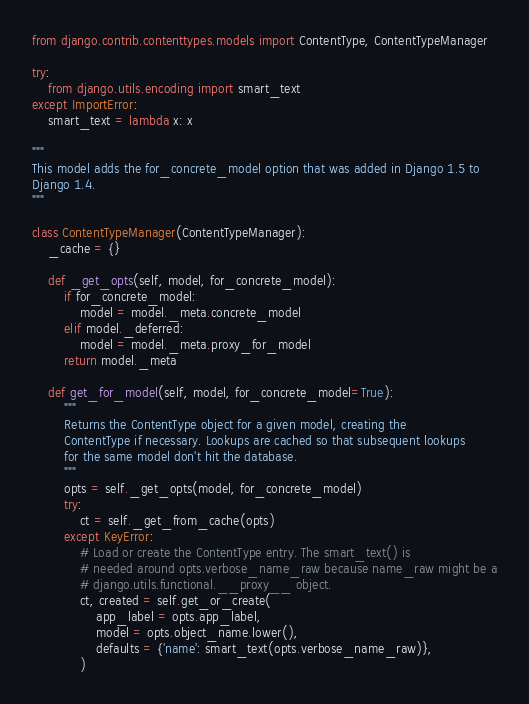Convert code to text. <code><loc_0><loc_0><loc_500><loc_500><_Python_>from django.contrib.contenttypes.models import ContentType, ContentTypeManager

try:
    from django.utils.encoding import smart_text
except ImportError:
    smart_text = lambda x: x

"""
This model adds the for_concrete_model option that was added in Django 1.5 to
Django 1.4.
"""

class ContentTypeManager(ContentTypeManager):
    _cache = {}

    def _get_opts(self, model, for_concrete_model):
        if for_concrete_model:
            model = model._meta.concrete_model
        elif model._deferred:
            model = model._meta.proxy_for_model
        return model._meta

    def get_for_model(self, model, for_concrete_model=True):
        """
        Returns the ContentType object for a given model, creating the
        ContentType if necessary. Lookups are cached so that subsequent lookups
        for the same model don't hit the database.
        """
        opts = self._get_opts(model, for_concrete_model)
        try:
            ct = self._get_from_cache(opts)
        except KeyError:
            # Load or create the ContentType entry. The smart_text() is
            # needed around opts.verbose_name_raw because name_raw might be a
            # django.utils.functional.__proxy__ object.
            ct, created = self.get_or_create(
                app_label = opts.app_label,
                model = opts.object_name.lower(),
                defaults = {'name': smart_text(opts.verbose_name_raw)},
            )</code> 